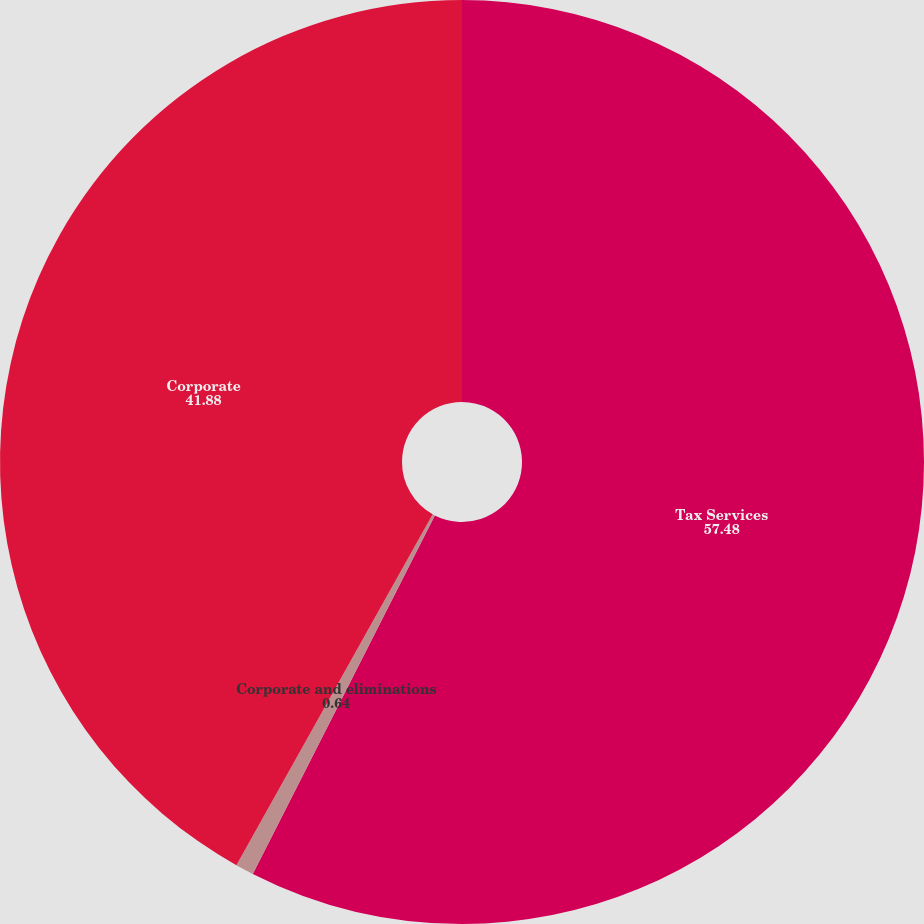<chart> <loc_0><loc_0><loc_500><loc_500><pie_chart><fcel>Tax Services<fcel>Corporate and eliminations<fcel>Corporate<nl><fcel>57.48%<fcel>0.64%<fcel>41.88%<nl></chart> 